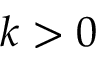<formula> <loc_0><loc_0><loc_500><loc_500>k > 0</formula> 